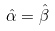Convert formula to latex. <formula><loc_0><loc_0><loc_500><loc_500>\hat { \alpha } = \hat { \beta }</formula> 